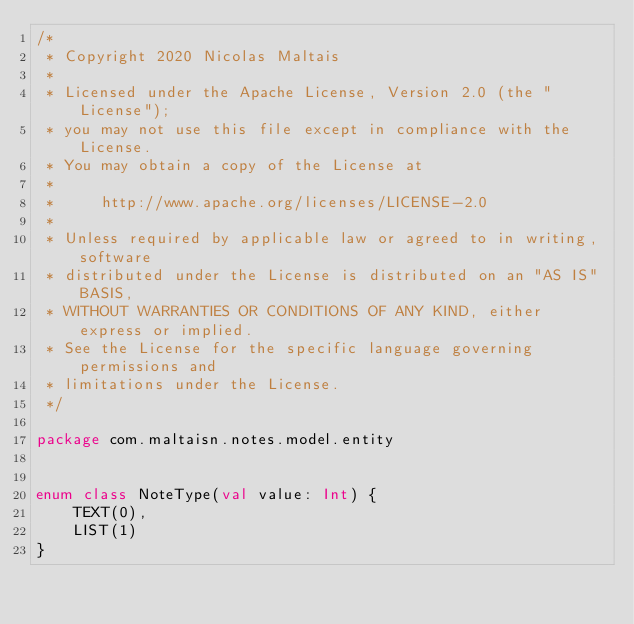Convert code to text. <code><loc_0><loc_0><loc_500><loc_500><_Kotlin_>/*
 * Copyright 2020 Nicolas Maltais
 *
 * Licensed under the Apache License, Version 2.0 (the "License");
 * you may not use this file except in compliance with the License.
 * You may obtain a copy of the License at
 *
 *     http://www.apache.org/licenses/LICENSE-2.0
 *
 * Unless required by applicable law or agreed to in writing, software
 * distributed under the License is distributed on an "AS IS" BASIS,
 * WITHOUT WARRANTIES OR CONDITIONS OF ANY KIND, either express or implied.
 * See the License for the specific language governing permissions and
 * limitations under the License.
 */

package com.maltaisn.notes.model.entity


enum class NoteType(val value: Int) {
    TEXT(0),
    LIST(1)
}
</code> 